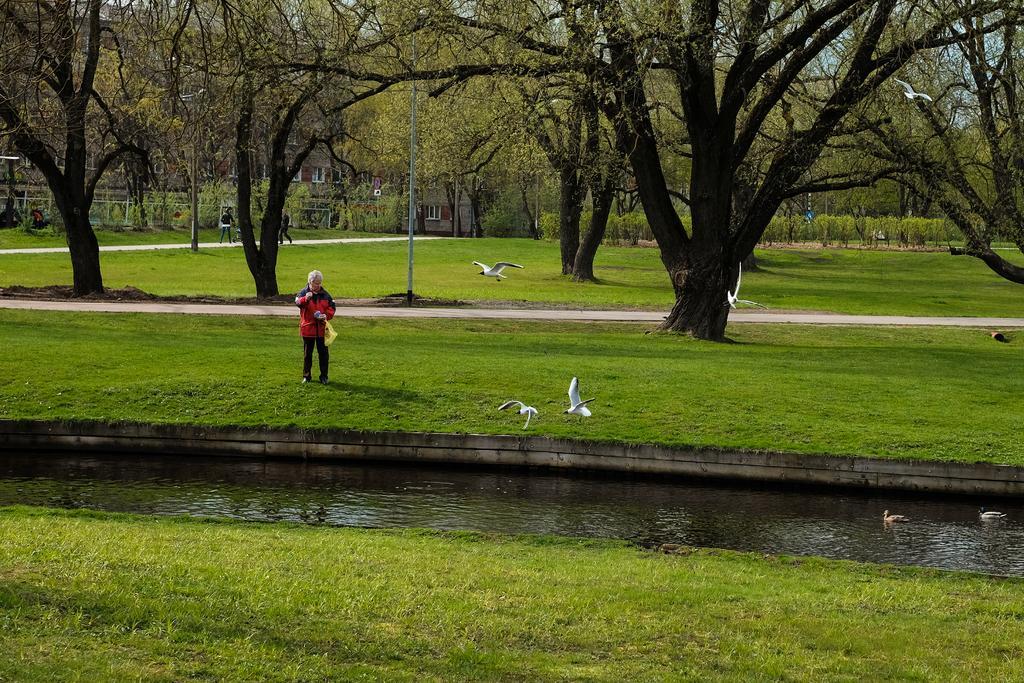How would you summarize this image in a sentence or two? In this image, we can see a person holding a carry bag and standing on the grass. At the bottom, we can see water. Here we can see birds. Few birds are flying in the air and two birds are floating on the water. Background we can see poles, people, walkways, trees, plants, grass and building. 